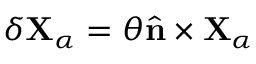Convert formula to latex. <formula><loc_0><loc_0><loc_500><loc_500>\delta { X } _ { \alpha } = \theta { \hat { n } } \times { X } _ { \alpha }</formula> 